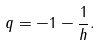<formula> <loc_0><loc_0><loc_500><loc_500>q = - 1 - \frac { 1 } { h } .</formula> 